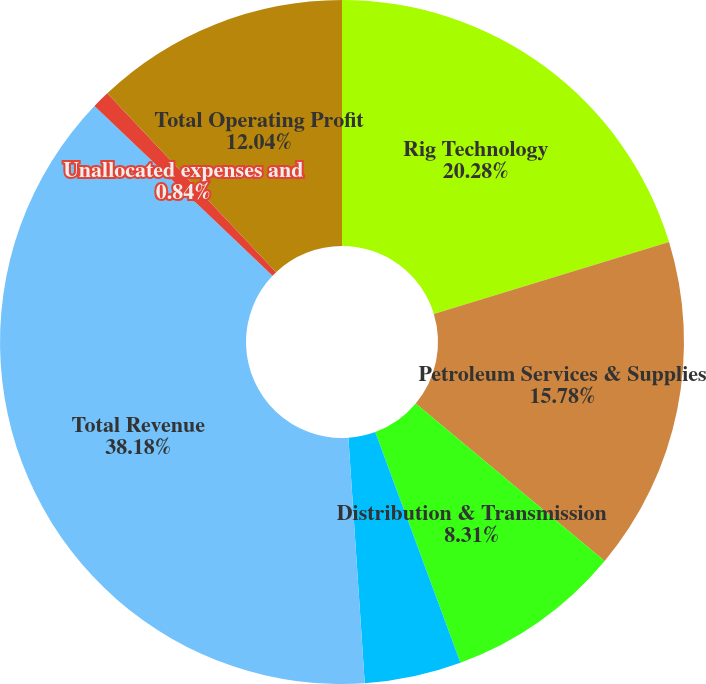Convert chart to OTSL. <chart><loc_0><loc_0><loc_500><loc_500><pie_chart><fcel>Rig Technology<fcel>Petroleum Services & Supplies<fcel>Distribution & Transmission<fcel>Eliminations<fcel>Total Revenue<fcel>Unallocated expenses and<fcel>Total Operating Profit<nl><fcel>20.28%<fcel>15.78%<fcel>8.31%<fcel>4.57%<fcel>38.18%<fcel>0.84%<fcel>12.04%<nl></chart> 